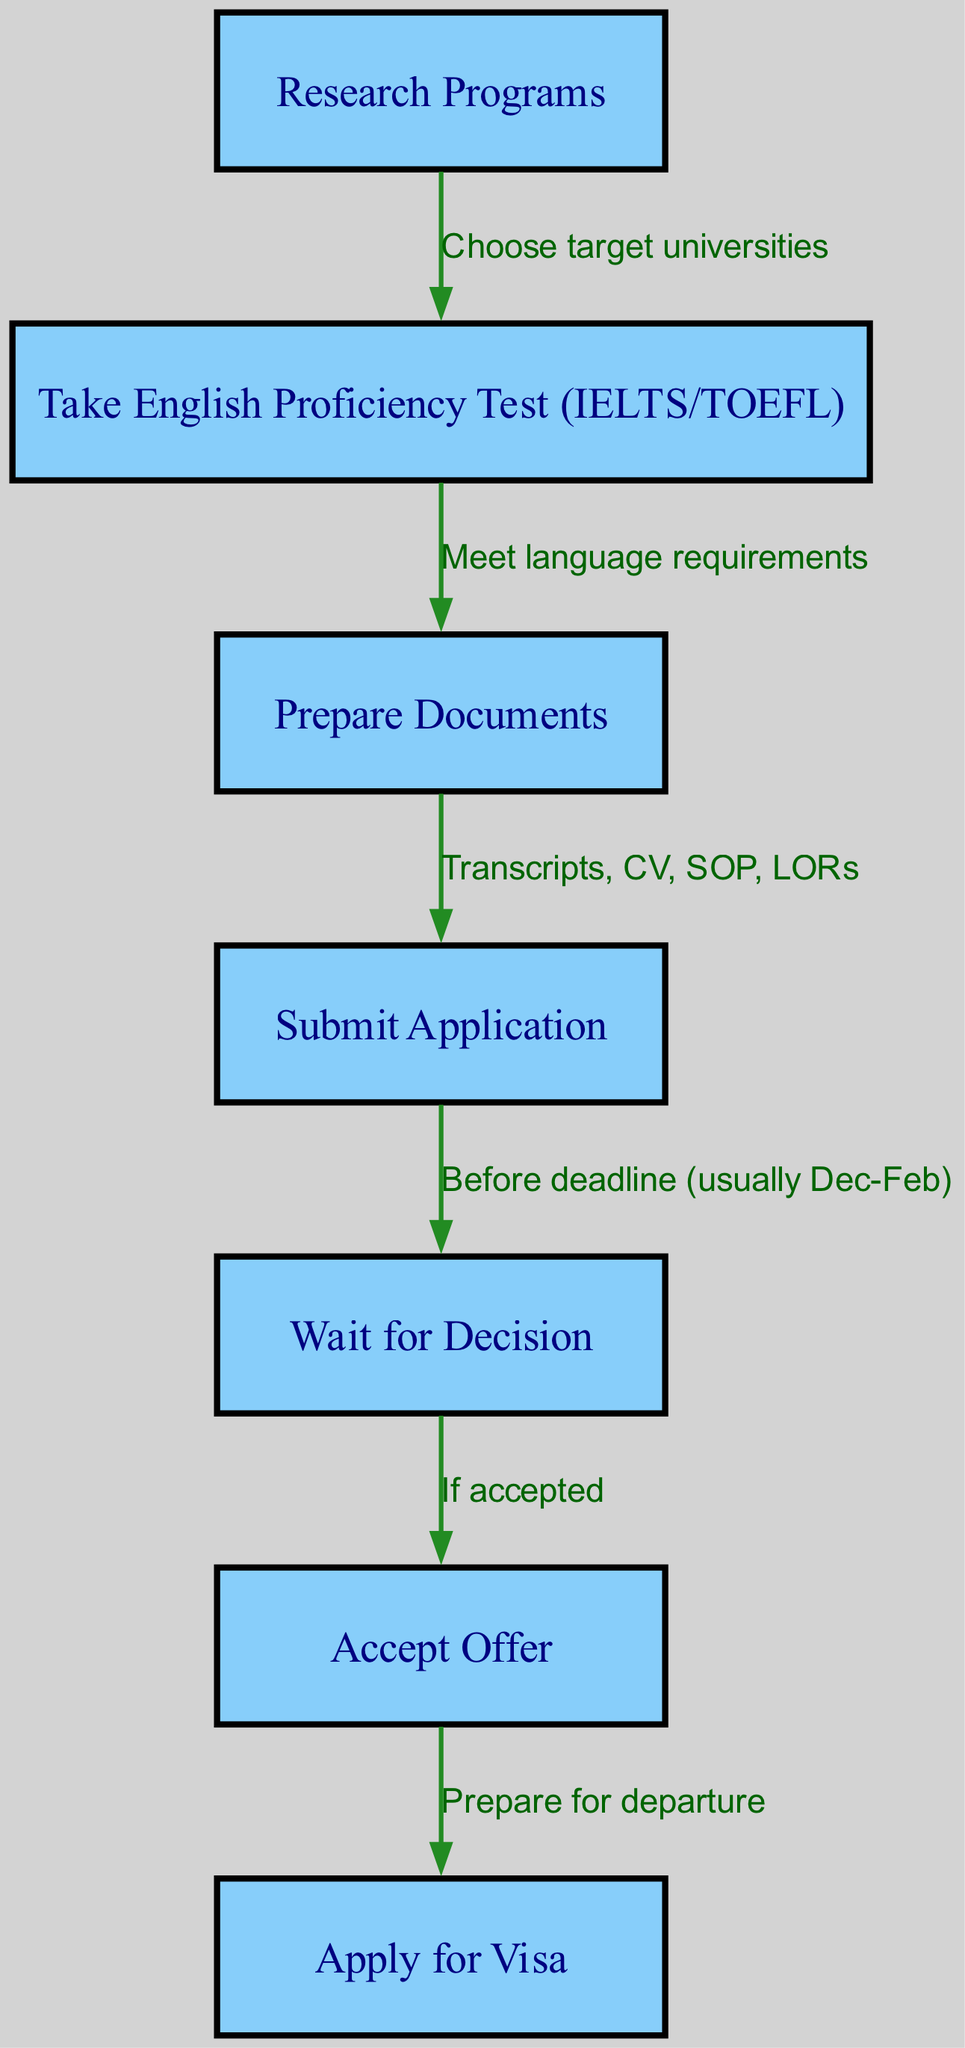What is the first step in the process? The diagram shows the first node labeled "Research Programs," indicating that this is the initial step to start the application process.
Answer: Research Programs How many total nodes are in the diagram? By counting all the nodes listed in the diagram, we find there are 7 nodes that represent different steps in the application process.
Answer: 7 What document types are required to prepare before submitting the application? The node "Prepare Documents" indicates that the required documents include transcripts, CV, SOP, and LORs, which are specified in the edge leading to this node.
Answer: Transcripts, CV, SOP, LORs What happens after submitting the application? The edge leading from "Submit Application" to "Wait for Decision" indicates that after the application is submitted, the next step is to wait for a decision.
Answer: Wait for Decision What must you do if you receive an acceptance offer? The diagram shows an edge leading from "Wait for Decision" to "Accept Offer," indicating that you must accept the offer if you get accepted.
Answer: Accept Offer What is the time frame indicated for submitting the application? The edge explains that submissions should occur before the deadline, which is usually between December and February. This specifies the time frame relevant to the application.
Answer: Before deadline (usually Dec-Feb) What is the last step illustrated in the diagram? The final node after "Accept Offer" is "Apply for Visa," indicating this as the last step in the flow after the acceptance of an offer.
Answer: Apply for Visa What must be met before taking the English proficiency test? The requirement stated in the edge from "Take English Proficiency Test (IELTS/TOEFL)" to "Prepare Documents" is that language requirements must be met beforehand.
Answer: Meet language requirements What do you need to do after accepting the offer? The flowchart indicates that after accepting the offer, you should prepare for departure, represented by the label "Prepare for departure."
Answer: Prepare for departure 